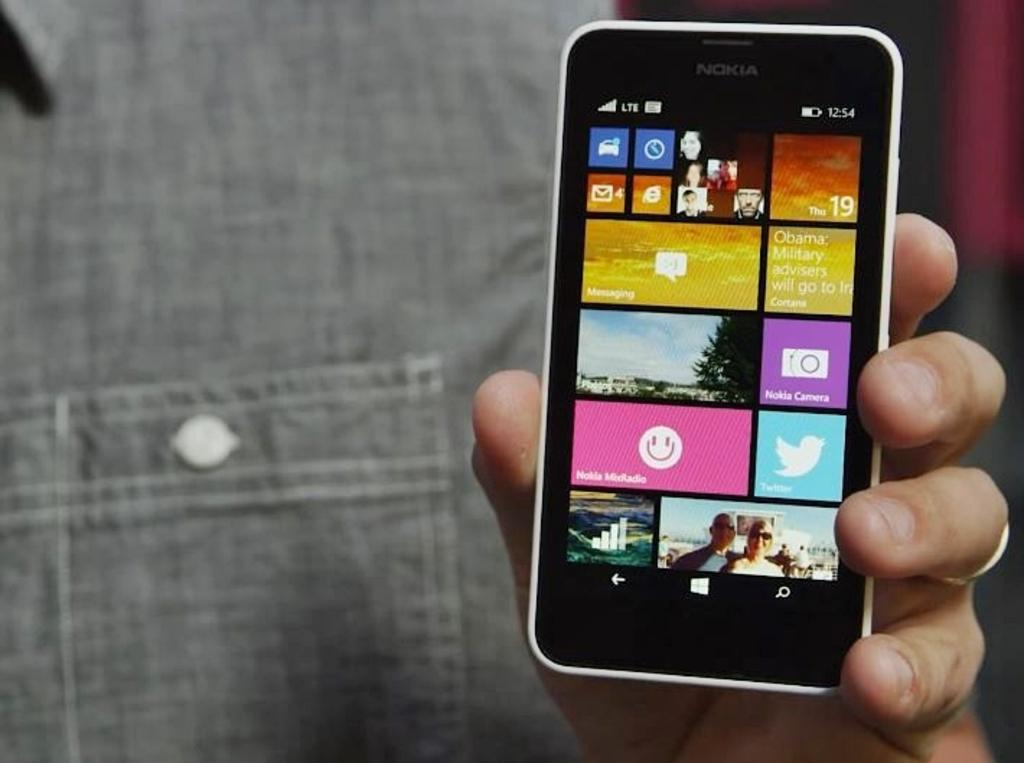<image>
Create a compact narrative representing the image presented. Many apps are shown on the screen including Nokia MixRadio and Nokia Camera. 